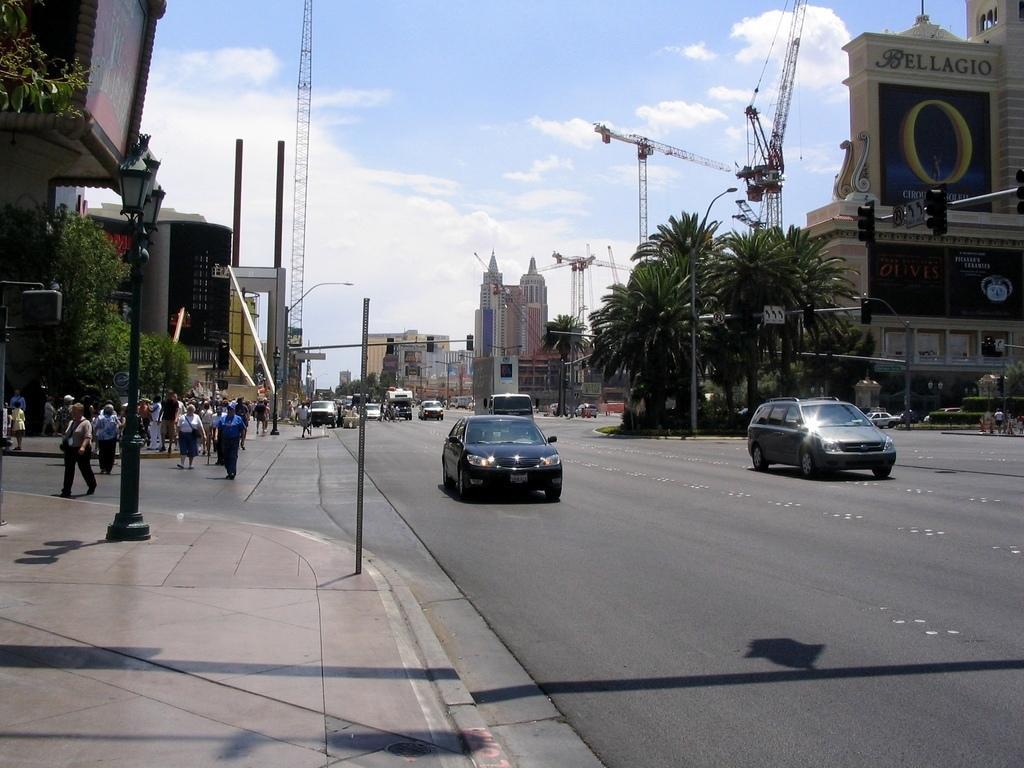Can you describe this image briefly? On the left side, there are lights lights attached to the pole and a small pole on the footpath. On the right side, there is a road on which there are vehicles. In the background, there are persons walking, there are buildings, towers and there are clouds in the blue sky. 